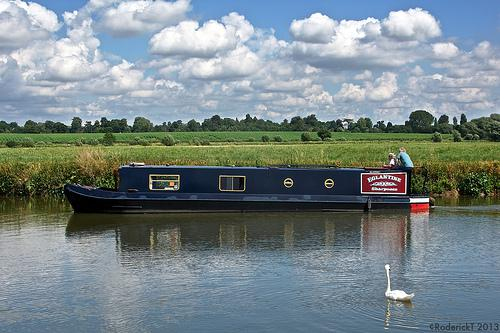Question: what is in the sky?
Choices:
A. A plane.
B. The sun.
C. Clouds.
D. A kite.
Answer with the letter. Answer: C Question: what color is the grass?
Choices:
A. Yellow.
B. Brown.
C. Green.
D. Orange.
Answer with the letter. Answer: C 